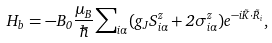Convert formula to latex. <formula><loc_0><loc_0><loc_500><loc_500>H _ { b } = - B _ { 0 } \frac { \mu _ { B } } \hbar { \sum } _ { i \alpha } ( g _ { J } S _ { i \alpha } ^ { z } + 2 \sigma _ { i \alpha } ^ { z } ) e ^ { - i \vec { K } \cdot \vec { R } _ { i } } ,</formula> 